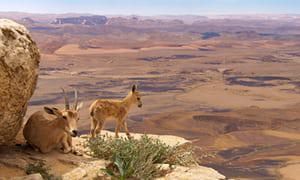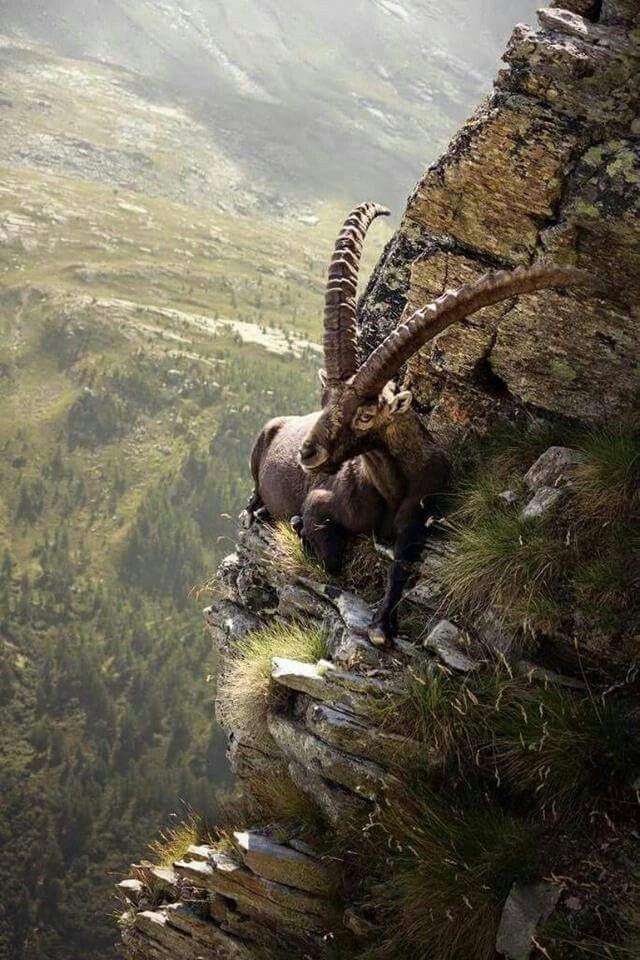The first image is the image on the left, the second image is the image on the right. Evaluate the accuracy of this statement regarding the images: "There are exactly four mountain goats total.". Is it true? Answer yes or no. No. The first image is the image on the left, the second image is the image on the right. For the images displayed, is the sentence "One image shows exactly one adult horned animal near at least one juvenile animal with no more than tiny horns." factually correct? Answer yes or no. Yes. 